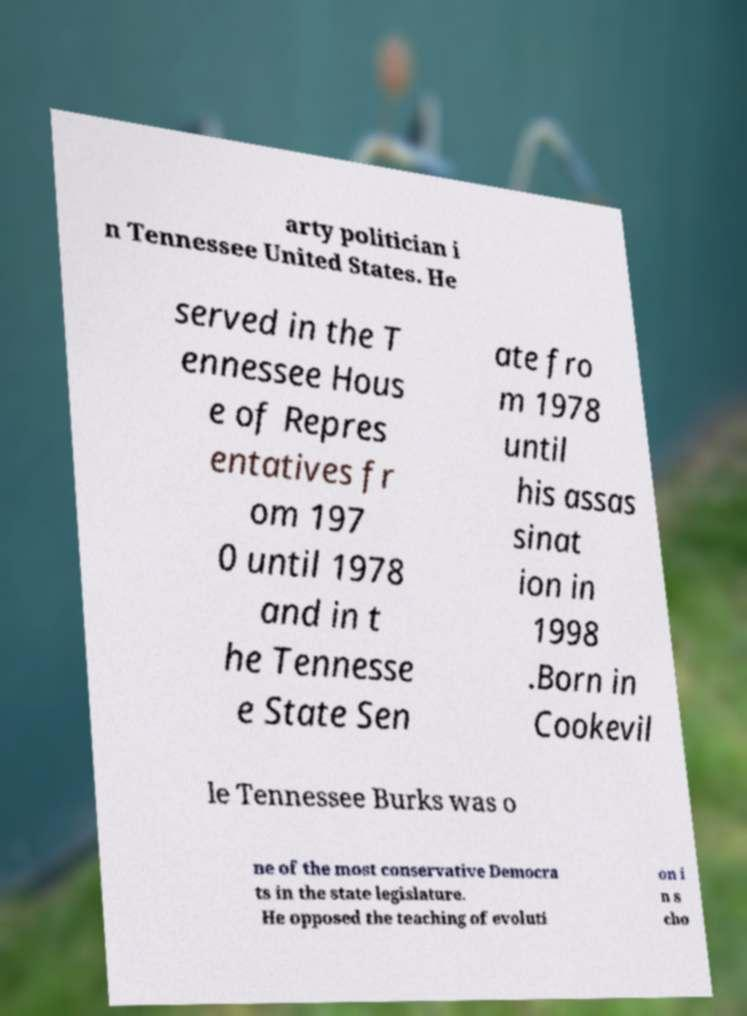There's text embedded in this image that I need extracted. Can you transcribe it verbatim? arty politician i n Tennessee United States. He served in the T ennessee Hous e of Repres entatives fr om 197 0 until 1978 and in t he Tennesse e State Sen ate fro m 1978 until his assas sinat ion in 1998 .Born in Cookevil le Tennessee Burks was o ne of the most conservative Democra ts in the state legislature. He opposed the teaching of evoluti on i n s cho 